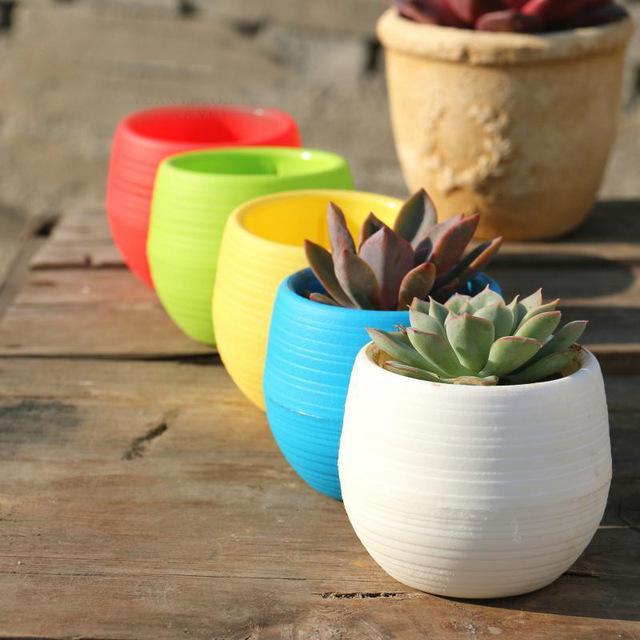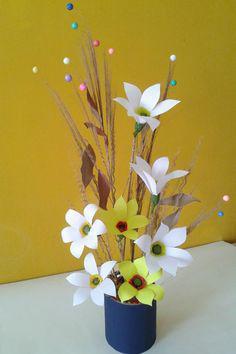The first image is the image on the left, the second image is the image on the right. Considering the images on both sides, is "One image shows at leat four faux flowers of different colors, and the other image shows a vase made out of stacked layers of oval shapes that are actually plastic spoons." valid? Answer yes or no. No. The first image is the image on the left, the second image is the image on the right. Evaluate the accuracy of this statement regarding the images: "In one of the images, there are more than one pots with plantlife in them.". Is it true? Answer yes or no. Yes. 